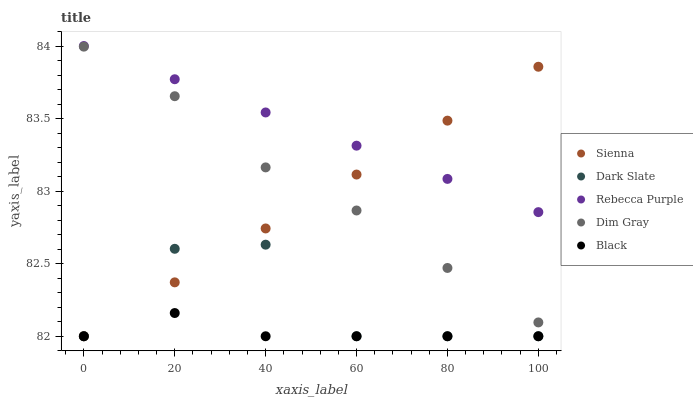Does Black have the minimum area under the curve?
Answer yes or no. Yes. Does Rebecca Purple have the maximum area under the curve?
Answer yes or no. Yes. Does Dark Slate have the minimum area under the curve?
Answer yes or no. No. Does Dark Slate have the maximum area under the curve?
Answer yes or no. No. Is Sienna the smoothest?
Answer yes or no. Yes. Is Dark Slate the roughest?
Answer yes or no. Yes. Is Dim Gray the smoothest?
Answer yes or no. No. Is Dim Gray the roughest?
Answer yes or no. No. Does Sienna have the lowest value?
Answer yes or no. Yes. Does Dim Gray have the lowest value?
Answer yes or no. No. Does Rebecca Purple have the highest value?
Answer yes or no. Yes. Does Dark Slate have the highest value?
Answer yes or no. No. Is Dim Gray less than Rebecca Purple?
Answer yes or no. Yes. Is Dim Gray greater than Dark Slate?
Answer yes or no. Yes. Does Dark Slate intersect Sienna?
Answer yes or no. Yes. Is Dark Slate less than Sienna?
Answer yes or no. No. Is Dark Slate greater than Sienna?
Answer yes or no. No. Does Dim Gray intersect Rebecca Purple?
Answer yes or no. No. 